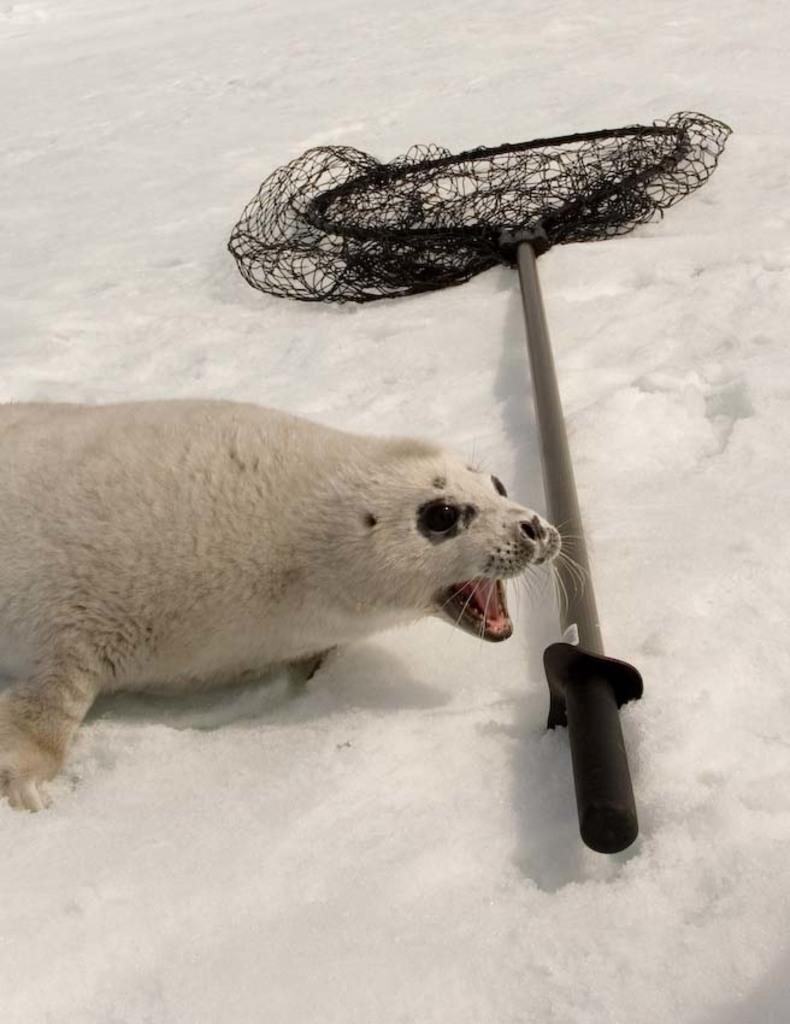What is the main subject on the left side of the image? There is an animal lying on the ice on the left side of the image. What object can be seen in the middle of the image? There is a net holder in the middle of the image. What is the primary color of the background in the image? The background of the image consists of white-colored ice. What type of surprise can be seen in the stocking hanging from the animal's neck in the image? There is no stocking or surprise present in the image; it only features an animal lying on the ice and a net holder. 